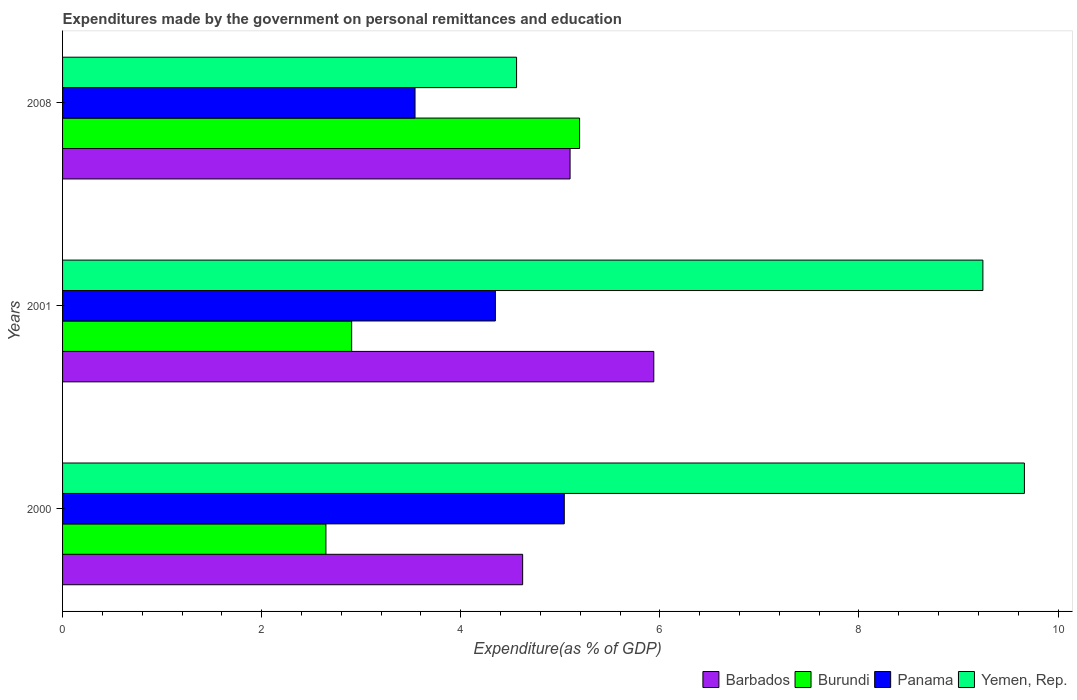How many groups of bars are there?
Your answer should be compact. 3. What is the expenditures made by the government on personal remittances and education in Yemen, Rep. in 2000?
Ensure brevity in your answer.  9.66. Across all years, what is the maximum expenditures made by the government on personal remittances and education in Panama?
Keep it short and to the point. 5.04. Across all years, what is the minimum expenditures made by the government on personal remittances and education in Panama?
Your answer should be very brief. 3.54. In which year was the expenditures made by the government on personal remittances and education in Panama maximum?
Your response must be concise. 2000. In which year was the expenditures made by the government on personal remittances and education in Panama minimum?
Offer a very short reply. 2008. What is the total expenditures made by the government on personal remittances and education in Panama in the graph?
Keep it short and to the point. 12.93. What is the difference between the expenditures made by the government on personal remittances and education in Yemen, Rep. in 2001 and that in 2008?
Make the answer very short. 4.68. What is the difference between the expenditures made by the government on personal remittances and education in Barbados in 2008 and the expenditures made by the government on personal remittances and education in Burundi in 2001?
Provide a short and direct response. 2.19. What is the average expenditures made by the government on personal remittances and education in Panama per year?
Offer a terse response. 4.31. In the year 2001, what is the difference between the expenditures made by the government on personal remittances and education in Panama and expenditures made by the government on personal remittances and education in Yemen, Rep.?
Offer a very short reply. -4.9. What is the ratio of the expenditures made by the government on personal remittances and education in Burundi in 2000 to that in 2008?
Provide a short and direct response. 0.51. Is the expenditures made by the government on personal remittances and education in Burundi in 2000 less than that in 2008?
Your answer should be very brief. Yes. Is the difference between the expenditures made by the government on personal remittances and education in Panama in 2000 and 2008 greater than the difference between the expenditures made by the government on personal remittances and education in Yemen, Rep. in 2000 and 2008?
Give a very brief answer. No. What is the difference between the highest and the second highest expenditures made by the government on personal remittances and education in Burundi?
Your answer should be very brief. 2.29. What is the difference between the highest and the lowest expenditures made by the government on personal remittances and education in Barbados?
Your answer should be compact. 1.32. Is the sum of the expenditures made by the government on personal remittances and education in Yemen, Rep. in 2001 and 2008 greater than the maximum expenditures made by the government on personal remittances and education in Barbados across all years?
Your answer should be compact. Yes. What does the 1st bar from the top in 2000 represents?
Your answer should be very brief. Yemen, Rep. What does the 4th bar from the bottom in 2008 represents?
Ensure brevity in your answer.  Yemen, Rep. How many bars are there?
Offer a terse response. 12. What is the difference between two consecutive major ticks on the X-axis?
Your answer should be very brief. 2. Does the graph contain grids?
Give a very brief answer. No. Where does the legend appear in the graph?
Give a very brief answer. Bottom right. How many legend labels are there?
Ensure brevity in your answer.  4. How are the legend labels stacked?
Make the answer very short. Horizontal. What is the title of the graph?
Make the answer very short. Expenditures made by the government on personal remittances and education. What is the label or title of the X-axis?
Keep it short and to the point. Expenditure(as % of GDP). What is the label or title of the Y-axis?
Provide a succinct answer. Years. What is the Expenditure(as % of GDP) of Barbados in 2000?
Keep it short and to the point. 4.62. What is the Expenditure(as % of GDP) of Burundi in 2000?
Your response must be concise. 2.65. What is the Expenditure(as % of GDP) of Panama in 2000?
Your answer should be very brief. 5.04. What is the Expenditure(as % of GDP) in Yemen, Rep. in 2000?
Provide a short and direct response. 9.66. What is the Expenditure(as % of GDP) of Barbados in 2001?
Keep it short and to the point. 5.94. What is the Expenditure(as % of GDP) of Burundi in 2001?
Provide a succinct answer. 2.9. What is the Expenditure(as % of GDP) of Panama in 2001?
Offer a terse response. 4.35. What is the Expenditure(as % of GDP) in Yemen, Rep. in 2001?
Provide a short and direct response. 9.24. What is the Expenditure(as % of GDP) in Barbados in 2008?
Your response must be concise. 5.1. What is the Expenditure(as % of GDP) of Burundi in 2008?
Provide a succinct answer. 5.19. What is the Expenditure(as % of GDP) in Panama in 2008?
Provide a short and direct response. 3.54. What is the Expenditure(as % of GDP) in Yemen, Rep. in 2008?
Your answer should be very brief. 4.56. Across all years, what is the maximum Expenditure(as % of GDP) of Barbados?
Give a very brief answer. 5.94. Across all years, what is the maximum Expenditure(as % of GDP) of Burundi?
Your answer should be compact. 5.19. Across all years, what is the maximum Expenditure(as % of GDP) in Panama?
Offer a terse response. 5.04. Across all years, what is the maximum Expenditure(as % of GDP) of Yemen, Rep.?
Your answer should be very brief. 9.66. Across all years, what is the minimum Expenditure(as % of GDP) of Barbados?
Provide a succinct answer. 4.62. Across all years, what is the minimum Expenditure(as % of GDP) in Burundi?
Your answer should be compact. 2.65. Across all years, what is the minimum Expenditure(as % of GDP) of Panama?
Your answer should be very brief. 3.54. Across all years, what is the minimum Expenditure(as % of GDP) of Yemen, Rep.?
Give a very brief answer. 4.56. What is the total Expenditure(as % of GDP) in Barbados in the graph?
Make the answer very short. 15.66. What is the total Expenditure(as % of GDP) of Burundi in the graph?
Offer a very short reply. 10.74. What is the total Expenditure(as % of GDP) in Panama in the graph?
Ensure brevity in your answer.  12.93. What is the total Expenditure(as % of GDP) in Yemen, Rep. in the graph?
Your answer should be compact. 23.47. What is the difference between the Expenditure(as % of GDP) in Barbados in 2000 and that in 2001?
Ensure brevity in your answer.  -1.32. What is the difference between the Expenditure(as % of GDP) of Burundi in 2000 and that in 2001?
Offer a terse response. -0.26. What is the difference between the Expenditure(as % of GDP) in Panama in 2000 and that in 2001?
Keep it short and to the point. 0.69. What is the difference between the Expenditure(as % of GDP) in Yemen, Rep. in 2000 and that in 2001?
Provide a succinct answer. 0.42. What is the difference between the Expenditure(as % of GDP) in Barbados in 2000 and that in 2008?
Make the answer very short. -0.48. What is the difference between the Expenditure(as % of GDP) in Burundi in 2000 and that in 2008?
Give a very brief answer. -2.55. What is the difference between the Expenditure(as % of GDP) of Panama in 2000 and that in 2008?
Make the answer very short. 1.5. What is the difference between the Expenditure(as % of GDP) in Yemen, Rep. in 2000 and that in 2008?
Offer a very short reply. 5.1. What is the difference between the Expenditure(as % of GDP) in Barbados in 2001 and that in 2008?
Give a very brief answer. 0.84. What is the difference between the Expenditure(as % of GDP) of Burundi in 2001 and that in 2008?
Give a very brief answer. -2.29. What is the difference between the Expenditure(as % of GDP) of Panama in 2001 and that in 2008?
Your answer should be compact. 0.81. What is the difference between the Expenditure(as % of GDP) in Yemen, Rep. in 2001 and that in 2008?
Give a very brief answer. 4.68. What is the difference between the Expenditure(as % of GDP) of Barbados in 2000 and the Expenditure(as % of GDP) of Burundi in 2001?
Provide a short and direct response. 1.72. What is the difference between the Expenditure(as % of GDP) of Barbados in 2000 and the Expenditure(as % of GDP) of Panama in 2001?
Your answer should be very brief. 0.27. What is the difference between the Expenditure(as % of GDP) of Barbados in 2000 and the Expenditure(as % of GDP) of Yemen, Rep. in 2001?
Your answer should be very brief. -4.62. What is the difference between the Expenditure(as % of GDP) in Burundi in 2000 and the Expenditure(as % of GDP) in Panama in 2001?
Provide a succinct answer. -1.7. What is the difference between the Expenditure(as % of GDP) of Burundi in 2000 and the Expenditure(as % of GDP) of Yemen, Rep. in 2001?
Offer a terse response. -6.6. What is the difference between the Expenditure(as % of GDP) of Panama in 2000 and the Expenditure(as % of GDP) of Yemen, Rep. in 2001?
Provide a succinct answer. -4.21. What is the difference between the Expenditure(as % of GDP) in Barbados in 2000 and the Expenditure(as % of GDP) in Burundi in 2008?
Your response must be concise. -0.57. What is the difference between the Expenditure(as % of GDP) of Barbados in 2000 and the Expenditure(as % of GDP) of Panama in 2008?
Your answer should be very brief. 1.08. What is the difference between the Expenditure(as % of GDP) in Barbados in 2000 and the Expenditure(as % of GDP) in Yemen, Rep. in 2008?
Your response must be concise. 0.06. What is the difference between the Expenditure(as % of GDP) of Burundi in 2000 and the Expenditure(as % of GDP) of Panama in 2008?
Your answer should be compact. -0.9. What is the difference between the Expenditure(as % of GDP) in Burundi in 2000 and the Expenditure(as % of GDP) in Yemen, Rep. in 2008?
Your response must be concise. -1.92. What is the difference between the Expenditure(as % of GDP) of Panama in 2000 and the Expenditure(as % of GDP) of Yemen, Rep. in 2008?
Provide a succinct answer. 0.48. What is the difference between the Expenditure(as % of GDP) in Barbados in 2001 and the Expenditure(as % of GDP) in Burundi in 2008?
Your response must be concise. 0.75. What is the difference between the Expenditure(as % of GDP) in Barbados in 2001 and the Expenditure(as % of GDP) in Panama in 2008?
Your answer should be very brief. 2.4. What is the difference between the Expenditure(as % of GDP) in Barbados in 2001 and the Expenditure(as % of GDP) in Yemen, Rep. in 2008?
Offer a very short reply. 1.38. What is the difference between the Expenditure(as % of GDP) in Burundi in 2001 and the Expenditure(as % of GDP) in Panama in 2008?
Offer a very short reply. -0.64. What is the difference between the Expenditure(as % of GDP) of Burundi in 2001 and the Expenditure(as % of GDP) of Yemen, Rep. in 2008?
Ensure brevity in your answer.  -1.66. What is the difference between the Expenditure(as % of GDP) in Panama in 2001 and the Expenditure(as % of GDP) in Yemen, Rep. in 2008?
Keep it short and to the point. -0.21. What is the average Expenditure(as % of GDP) of Barbados per year?
Provide a succinct answer. 5.22. What is the average Expenditure(as % of GDP) of Burundi per year?
Offer a terse response. 3.58. What is the average Expenditure(as % of GDP) in Panama per year?
Provide a succinct answer. 4.31. What is the average Expenditure(as % of GDP) in Yemen, Rep. per year?
Offer a terse response. 7.82. In the year 2000, what is the difference between the Expenditure(as % of GDP) of Barbados and Expenditure(as % of GDP) of Burundi?
Give a very brief answer. 1.98. In the year 2000, what is the difference between the Expenditure(as % of GDP) of Barbados and Expenditure(as % of GDP) of Panama?
Ensure brevity in your answer.  -0.42. In the year 2000, what is the difference between the Expenditure(as % of GDP) in Barbados and Expenditure(as % of GDP) in Yemen, Rep.?
Your answer should be compact. -5.04. In the year 2000, what is the difference between the Expenditure(as % of GDP) in Burundi and Expenditure(as % of GDP) in Panama?
Your response must be concise. -2.39. In the year 2000, what is the difference between the Expenditure(as % of GDP) in Burundi and Expenditure(as % of GDP) in Yemen, Rep.?
Give a very brief answer. -7.02. In the year 2000, what is the difference between the Expenditure(as % of GDP) in Panama and Expenditure(as % of GDP) in Yemen, Rep.?
Offer a terse response. -4.62. In the year 2001, what is the difference between the Expenditure(as % of GDP) of Barbados and Expenditure(as % of GDP) of Burundi?
Your answer should be very brief. 3.04. In the year 2001, what is the difference between the Expenditure(as % of GDP) in Barbados and Expenditure(as % of GDP) in Panama?
Keep it short and to the point. 1.59. In the year 2001, what is the difference between the Expenditure(as % of GDP) in Barbados and Expenditure(as % of GDP) in Yemen, Rep.?
Your response must be concise. -3.31. In the year 2001, what is the difference between the Expenditure(as % of GDP) in Burundi and Expenditure(as % of GDP) in Panama?
Offer a terse response. -1.44. In the year 2001, what is the difference between the Expenditure(as % of GDP) in Burundi and Expenditure(as % of GDP) in Yemen, Rep.?
Your answer should be compact. -6.34. In the year 2001, what is the difference between the Expenditure(as % of GDP) in Panama and Expenditure(as % of GDP) in Yemen, Rep.?
Your answer should be compact. -4.9. In the year 2008, what is the difference between the Expenditure(as % of GDP) in Barbados and Expenditure(as % of GDP) in Burundi?
Ensure brevity in your answer.  -0.1. In the year 2008, what is the difference between the Expenditure(as % of GDP) of Barbados and Expenditure(as % of GDP) of Panama?
Offer a very short reply. 1.56. In the year 2008, what is the difference between the Expenditure(as % of GDP) in Barbados and Expenditure(as % of GDP) in Yemen, Rep.?
Give a very brief answer. 0.54. In the year 2008, what is the difference between the Expenditure(as % of GDP) of Burundi and Expenditure(as % of GDP) of Panama?
Ensure brevity in your answer.  1.65. In the year 2008, what is the difference between the Expenditure(as % of GDP) of Burundi and Expenditure(as % of GDP) of Yemen, Rep.?
Provide a succinct answer. 0.63. In the year 2008, what is the difference between the Expenditure(as % of GDP) in Panama and Expenditure(as % of GDP) in Yemen, Rep.?
Ensure brevity in your answer.  -1.02. What is the ratio of the Expenditure(as % of GDP) of Barbados in 2000 to that in 2001?
Your answer should be compact. 0.78. What is the ratio of the Expenditure(as % of GDP) in Burundi in 2000 to that in 2001?
Ensure brevity in your answer.  0.91. What is the ratio of the Expenditure(as % of GDP) in Panama in 2000 to that in 2001?
Provide a short and direct response. 1.16. What is the ratio of the Expenditure(as % of GDP) of Yemen, Rep. in 2000 to that in 2001?
Ensure brevity in your answer.  1.05. What is the ratio of the Expenditure(as % of GDP) of Barbados in 2000 to that in 2008?
Keep it short and to the point. 0.91. What is the ratio of the Expenditure(as % of GDP) in Burundi in 2000 to that in 2008?
Your answer should be very brief. 0.51. What is the ratio of the Expenditure(as % of GDP) in Panama in 2000 to that in 2008?
Offer a terse response. 1.42. What is the ratio of the Expenditure(as % of GDP) of Yemen, Rep. in 2000 to that in 2008?
Provide a short and direct response. 2.12. What is the ratio of the Expenditure(as % of GDP) in Barbados in 2001 to that in 2008?
Offer a terse response. 1.17. What is the ratio of the Expenditure(as % of GDP) in Burundi in 2001 to that in 2008?
Offer a terse response. 0.56. What is the ratio of the Expenditure(as % of GDP) of Panama in 2001 to that in 2008?
Keep it short and to the point. 1.23. What is the ratio of the Expenditure(as % of GDP) of Yemen, Rep. in 2001 to that in 2008?
Provide a succinct answer. 2.03. What is the difference between the highest and the second highest Expenditure(as % of GDP) in Barbados?
Make the answer very short. 0.84. What is the difference between the highest and the second highest Expenditure(as % of GDP) in Burundi?
Provide a succinct answer. 2.29. What is the difference between the highest and the second highest Expenditure(as % of GDP) in Panama?
Keep it short and to the point. 0.69. What is the difference between the highest and the second highest Expenditure(as % of GDP) of Yemen, Rep.?
Provide a succinct answer. 0.42. What is the difference between the highest and the lowest Expenditure(as % of GDP) in Barbados?
Provide a succinct answer. 1.32. What is the difference between the highest and the lowest Expenditure(as % of GDP) in Burundi?
Make the answer very short. 2.55. What is the difference between the highest and the lowest Expenditure(as % of GDP) of Panama?
Ensure brevity in your answer.  1.5. What is the difference between the highest and the lowest Expenditure(as % of GDP) in Yemen, Rep.?
Your answer should be very brief. 5.1. 